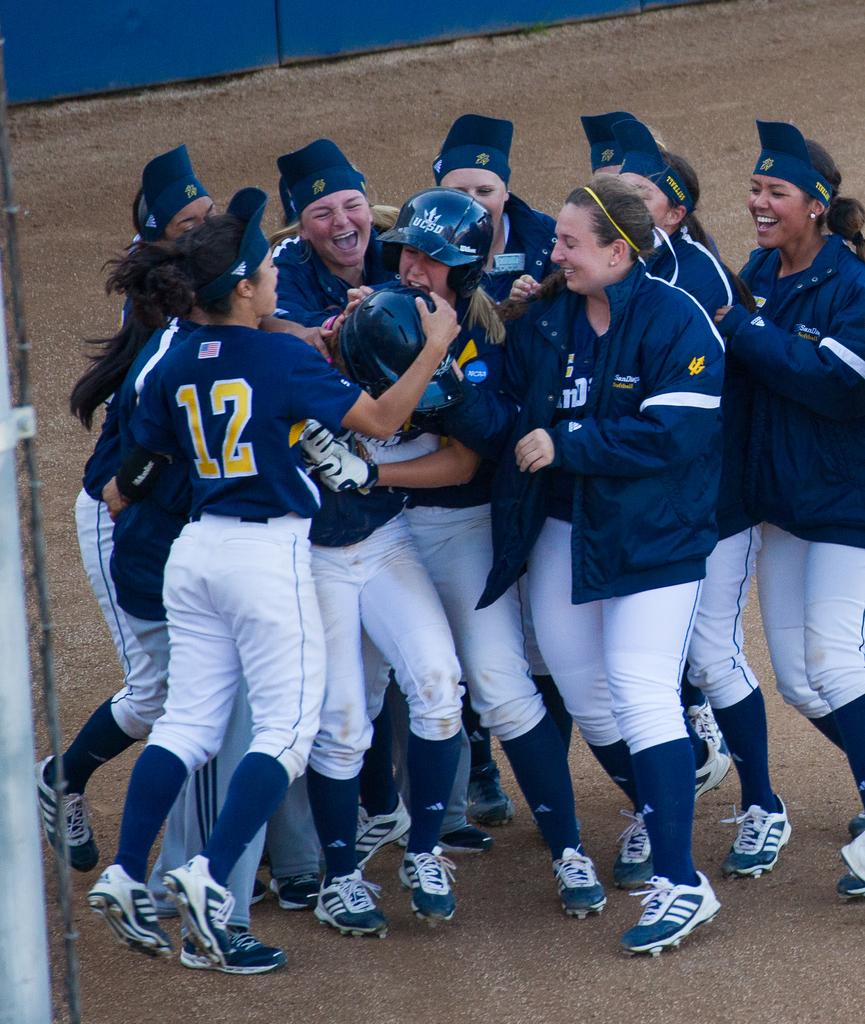<image>
Render a clear and concise summary of the photo. A group of UCSD softball players huddle around one player cheering. 